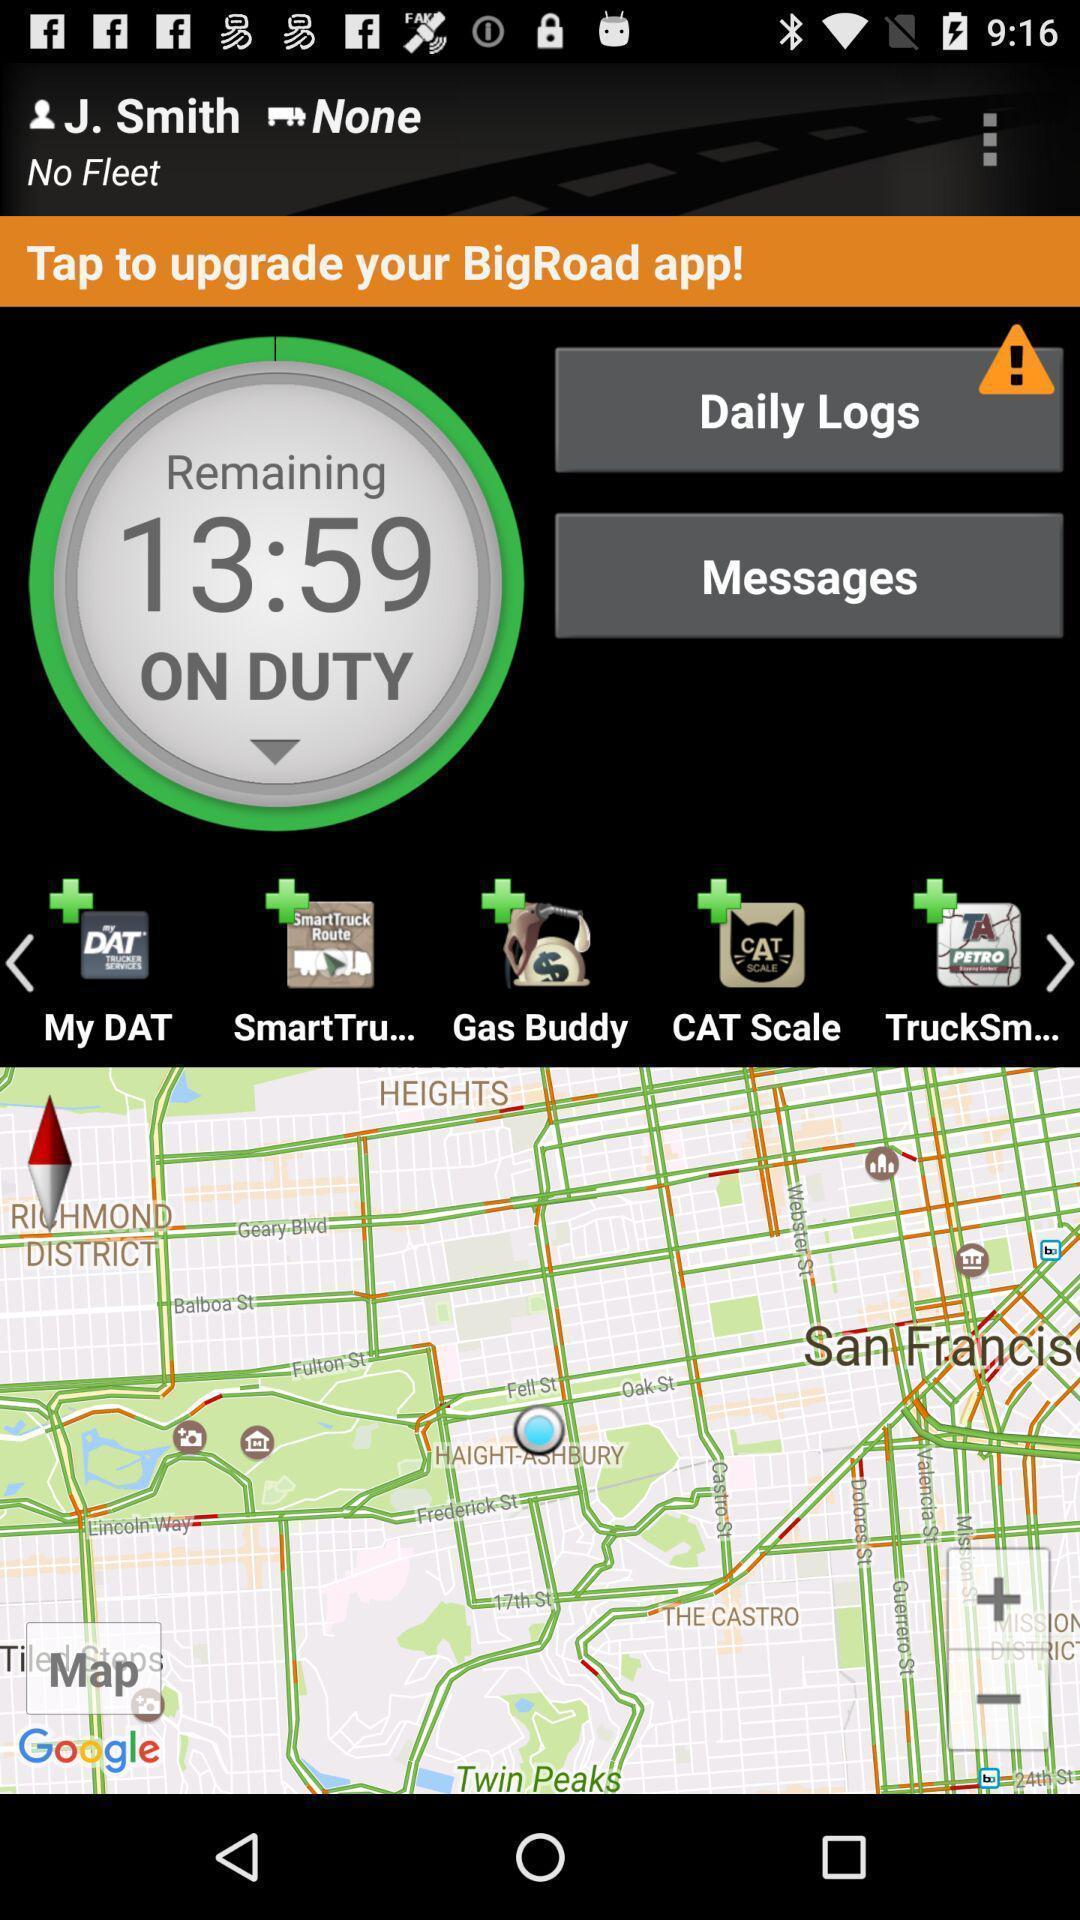What details can you identify in this image? Page displaying the daily logs. 